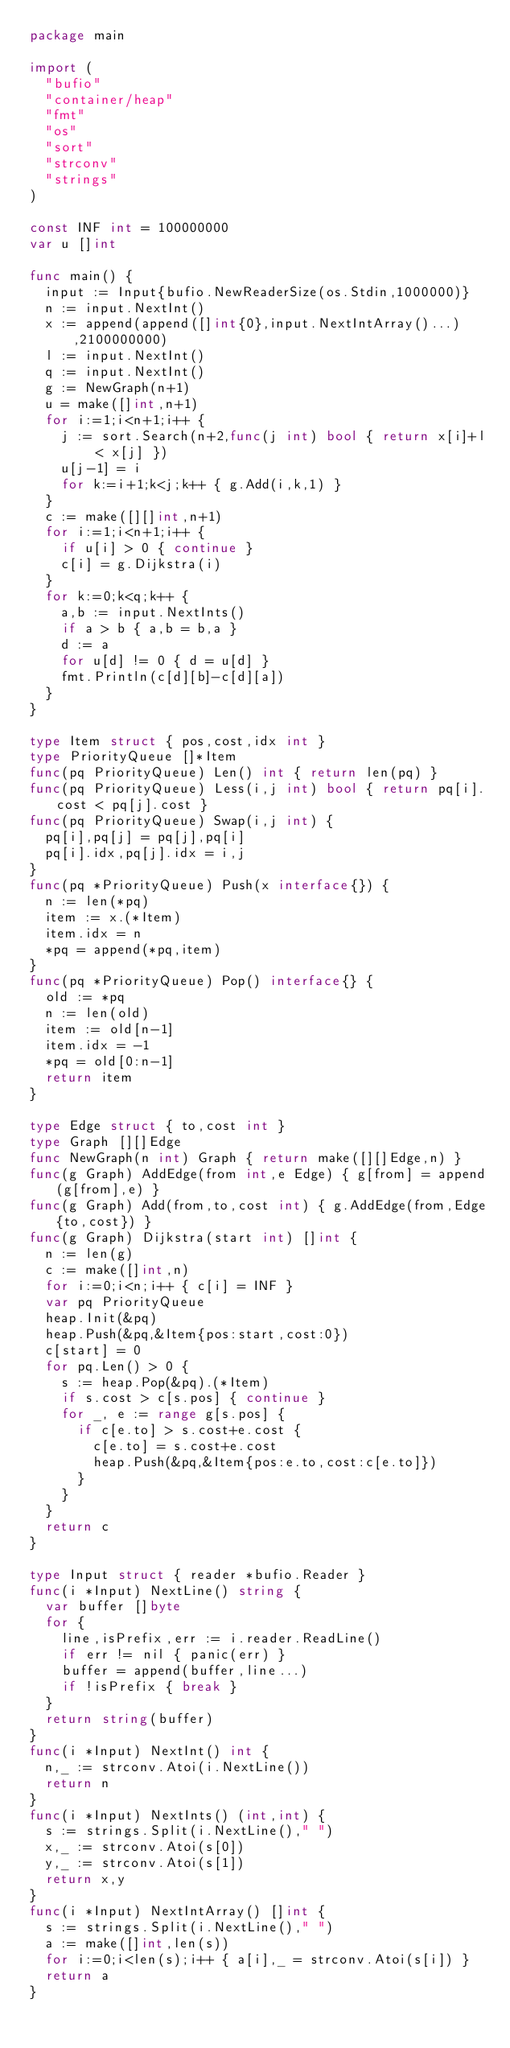<code> <loc_0><loc_0><loc_500><loc_500><_Go_>package main

import (
  "bufio"
  "container/heap"
  "fmt"
  "os"
  "sort"
  "strconv"
  "strings"
)

const INF int = 100000000
var u []int

func main() {
  input := Input{bufio.NewReaderSize(os.Stdin,1000000)}
  n := input.NextInt()
  x := append(append([]int{0},input.NextIntArray()...),2100000000)
  l := input.NextInt()
  q := input.NextInt()
  g := NewGraph(n+1)
  u = make([]int,n+1)
  for i:=1;i<n+1;i++ {
    j := sort.Search(n+2,func(j int) bool { return x[i]+l < x[j] })
    u[j-1] = i
    for k:=i+1;k<j;k++ { g.Add(i,k,1) }
  }
  c := make([][]int,n+1)
  for i:=1;i<n+1;i++ {
    if u[i] > 0 { continue }
    c[i] = g.Dijkstra(i)
  }
  for k:=0;k<q;k++ {
    a,b := input.NextInts()
    if a > b { a,b = b,a }
    d := a
    for u[d] != 0 { d = u[d] }
    fmt.Println(c[d][b]-c[d][a])
  }
}

type Item struct { pos,cost,idx int }
type PriorityQueue []*Item
func(pq PriorityQueue) Len() int { return len(pq) }
func(pq PriorityQueue) Less(i,j int) bool { return pq[i].cost < pq[j].cost }
func(pq PriorityQueue) Swap(i,j int) {
  pq[i],pq[j] = pq[j],pq[i]
  pq[i].idx,pq[j].idx = i,j
}
func(pq *PriorityQueue) Push(x interface{}) {
  n := len(*pq)
  item := x.(*Item)
  item.idx = n
  *pq = append(*pq,item)
}
func(pq *PriorityQueue) Pop() interface{} {
  old := *pq
  n := len(old)
  item := old[n-1]
  item.idx = -1
  *pq = old[0:n-1]
  return item
}

type Edge struct { to,cost int }
type Graph [][]Edge
func NewGraph(n int) Graph { return make([][]Edge,n) }
func(g Graph) AddEdge(from int,e Edge) { g[from] = append(g[from],e) }
func(g Graph) Add(from,to,cost int) { g.AddEdge(from,Edge{to,cost}) }
func(g Graph) Dijkstra(start int) []int {
  n := len(g)
  c := make([]int,n)
  for i:=0;i<n;i++ { c[i] = INF }
  var pq PriorityQueue
  heap.Init(&pq)
  heap.Push(&pq,&Item{pos:start,cost:0})
  c[start] = 0
  for pq.Len() > 0 {
    s := heap.Pop(&pq).(*Item)
    if s.cost > c[s.pos] { continue }
    for _, e := range g[s.pos] {
      if c[e.to] > s.cost+e.cost {
        c[e.to] = s.cost+e.cost
        heap.Push(&pq,&Item{pos:e.to,cost:c[e.to]})
      }
    }
  }
  return c
}

type Input struct { reader *bufio.Reader }
func(i *Input) NextLine() string {
  var buffer []byte
  for {
    line,isPrefix,err := i.reader.ReadLine()
    if err != nil { panic(err) }
    buffer = append(buffer,line...)
    if !isPrefix { break }
  }
  return string(buffer)
}
func(i *Input) NextInt() int {
  n,_ := strconv.Atoi(i.NextLine())
  return n
}
func(i *Input) NextInts() (int,int) {
  s := strings.Split(i.NextLine()," ")
  x,_ := strconv.Atoi(s[0])
  y,_ := strconv.Atoi(s[1])
  return x,y
}
func(i *Input) NextIntArray() []int {
  s := strings.Split(i.NextLine()," ")
  a := make([]int,len(s))
  for i:=0;i<len(s);i++ { a[i],_ = strconv.Atoi(s[i]) }
  return a
}</code> 